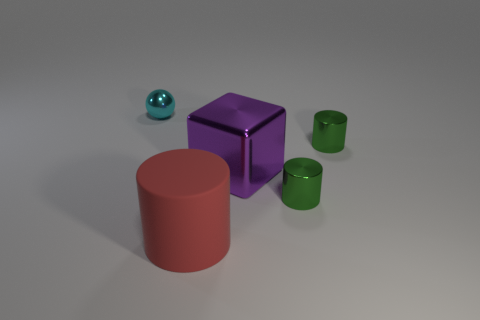Subtract all large red cylinders. How many cylinders are left? 2 Add 4 red metallic balls. How many objects exist? 9 Subtract all green cylinders. How many cylinders are left? 1 Subtract all blocks. How many objects are left? 4 Subtract 1 balls. How many balls are left? 0 Add 4 large blue balls. How many large blue balls exist? 4 Subtract 1 red cylinders. How many objects are left? 4 Subtract all cyan cylinders. Subtract all green blocks. How many cylinders are left? 3 Subtract all yellow cylinders. How many brown cubes are left? 0 Subtract all large red matte cylinders. Subtract all cyan metallic spheres. How many objects are left? 3 